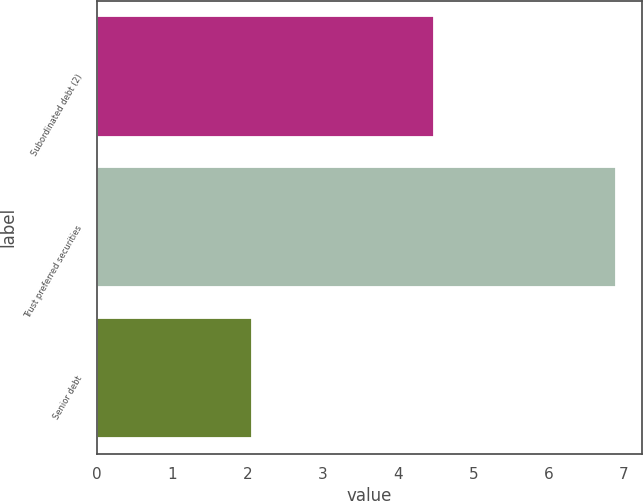Convert chart to OTSL. <chart><loc_0><loc_0><loc_500><loc_500><bar_chart><fcel>Subordinated debt (2)<fcel>Trust preferred securities<fcel>Senior debt<nl><fcel>4.48<fcel>6.9<fcel>2.06<nl></chart> 